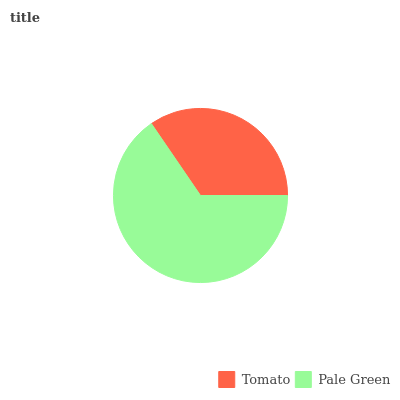Is Tomato the minimum?
Answer yes or no. Yes. Is Pale Green the maximum?
Answer yes or no. Yes. Is Pale Green the minimum?
Answer yes or no. No. Is Pale Green greater than Tomato?
Answer yes or no. Yes. Is Tomato less than Pale Green?
Answer yes or no. Yes. Is Tomato greater than Pale Green?
Answer yes or no. No. Is Pale Green less than Tomato?
Answer yes or no. No. Is Pale Green the high median?
Answer yes or no. Yes. Is Tomato the low median?
Answer yes or no. Yes. Is Tomato the high median?
Answer yes or no. No. Is Pale Green the low median?
Answer yes or no. No. 